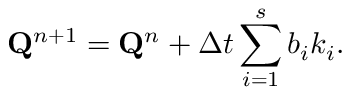Convert formula to latex. <formula><loc_0><loc_0><loc_500><loc_500>Q ^ { n + 1 } = Q ^ { n } + { \Delta t } \sum _ { i = 1 } ^ { s } b _ { i } k _ { i } .</formula> 